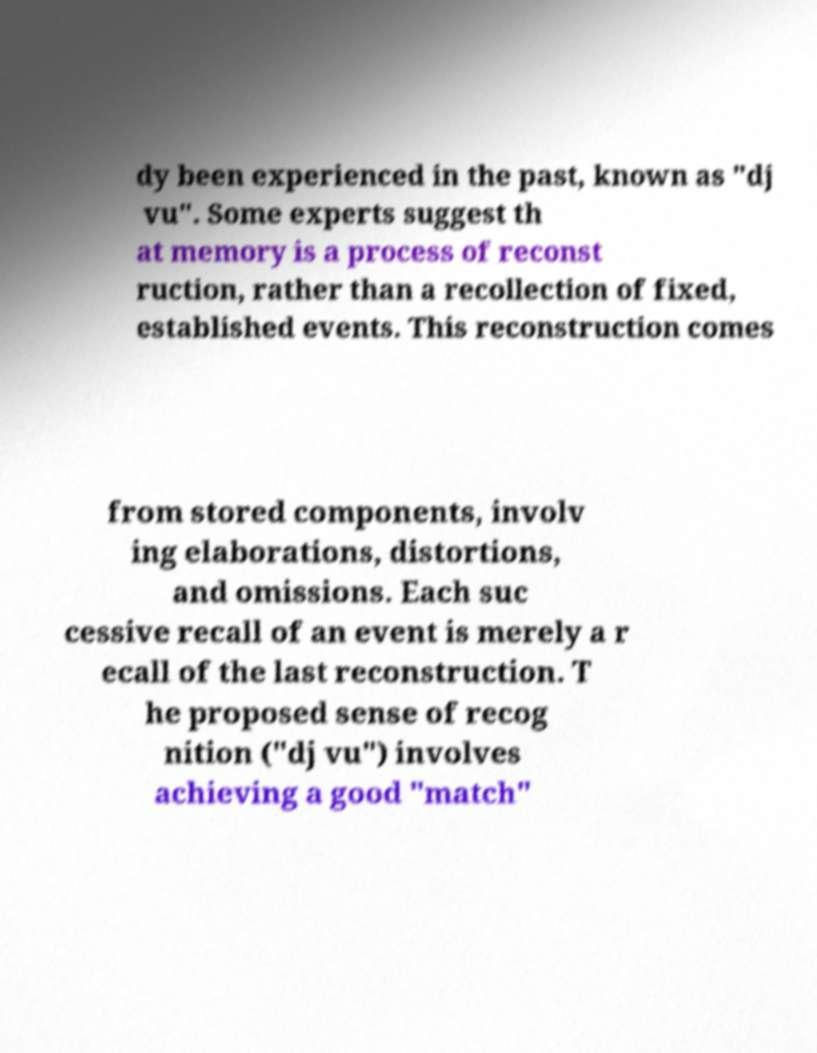Could you assist in decoding the text presented in this image and type it out clearly? dy been experienced in the past, known as "dj vu". Some experts suggest th at memory is a process of reconst ruction, rather than a recollection of fixed, established events. This reconstruction comes from stored components, involv ing elaborations, distortions, and omissions. Each suc cessive recall of an event is merely a r ecall of the last reconstruction. T he proposed sense of recog nition ("dj vu") involves achieving a good "match" 